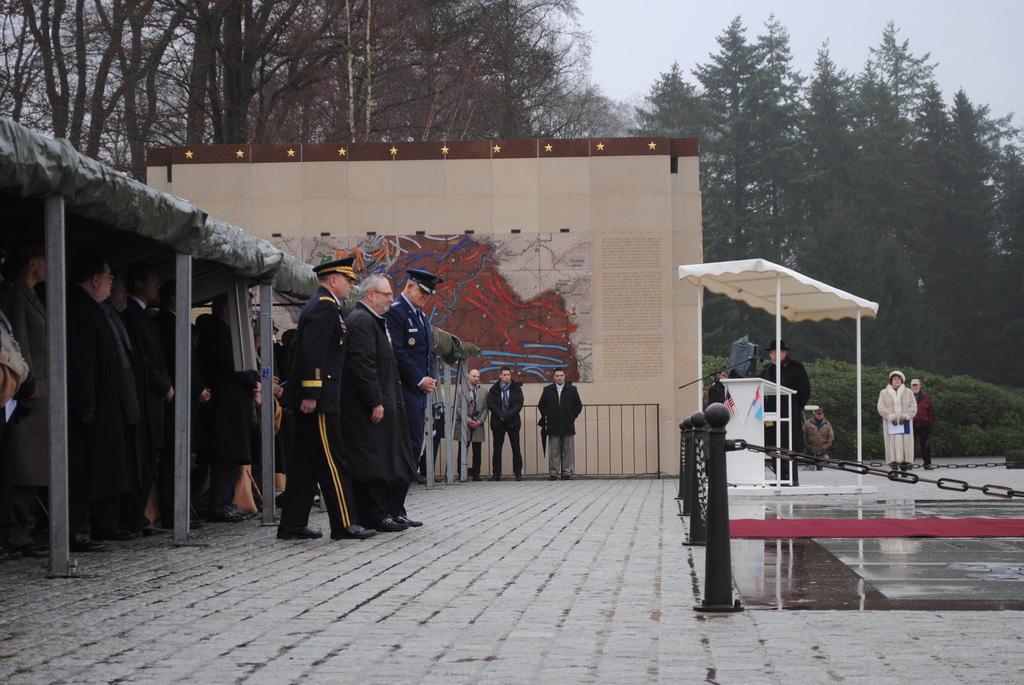In one or two sentences, can you explain what this image depicts? There are groups of people standing. This looks like a podium with a mike. I think these are the iron chains, which are attached to the iron poles. This is the red carpet on the floor. These are the trees and bushes. This looks like a shelter. These are the iron pillars. I think this is a poster. 